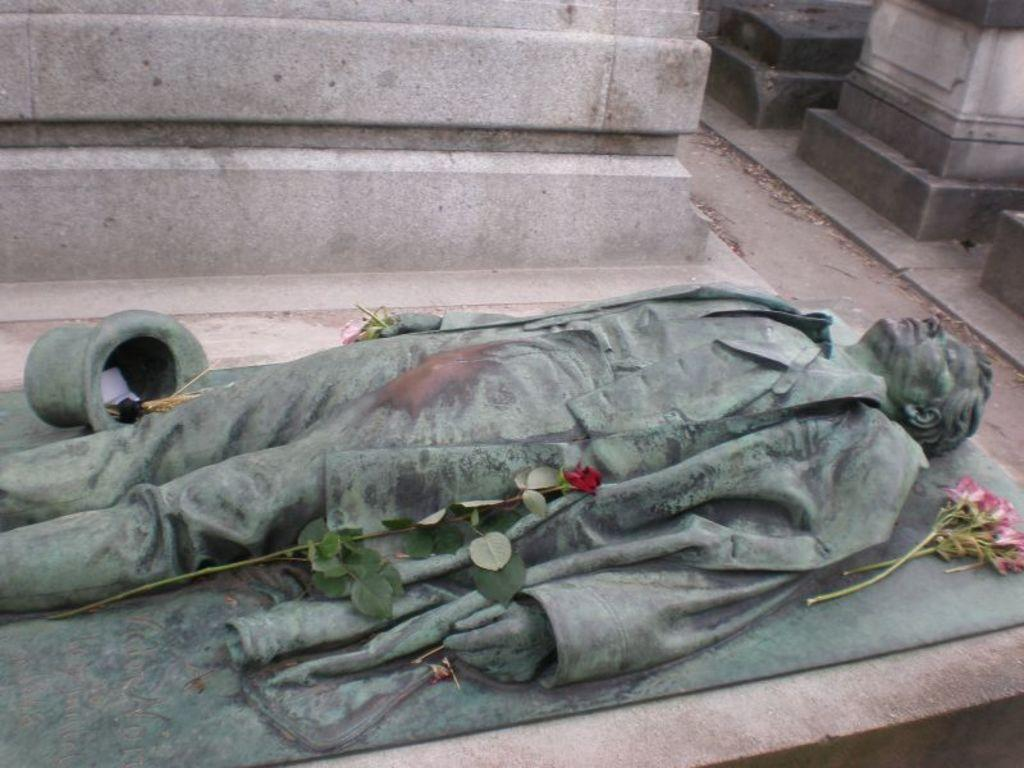What is the main subject of the image? There is a sculpture in the image. What other elements can be seen in the image? There are flowers in the image. How much money is the slave carrying in the image? There is no slave or money present in the image; it features a sculpture and flowers. 